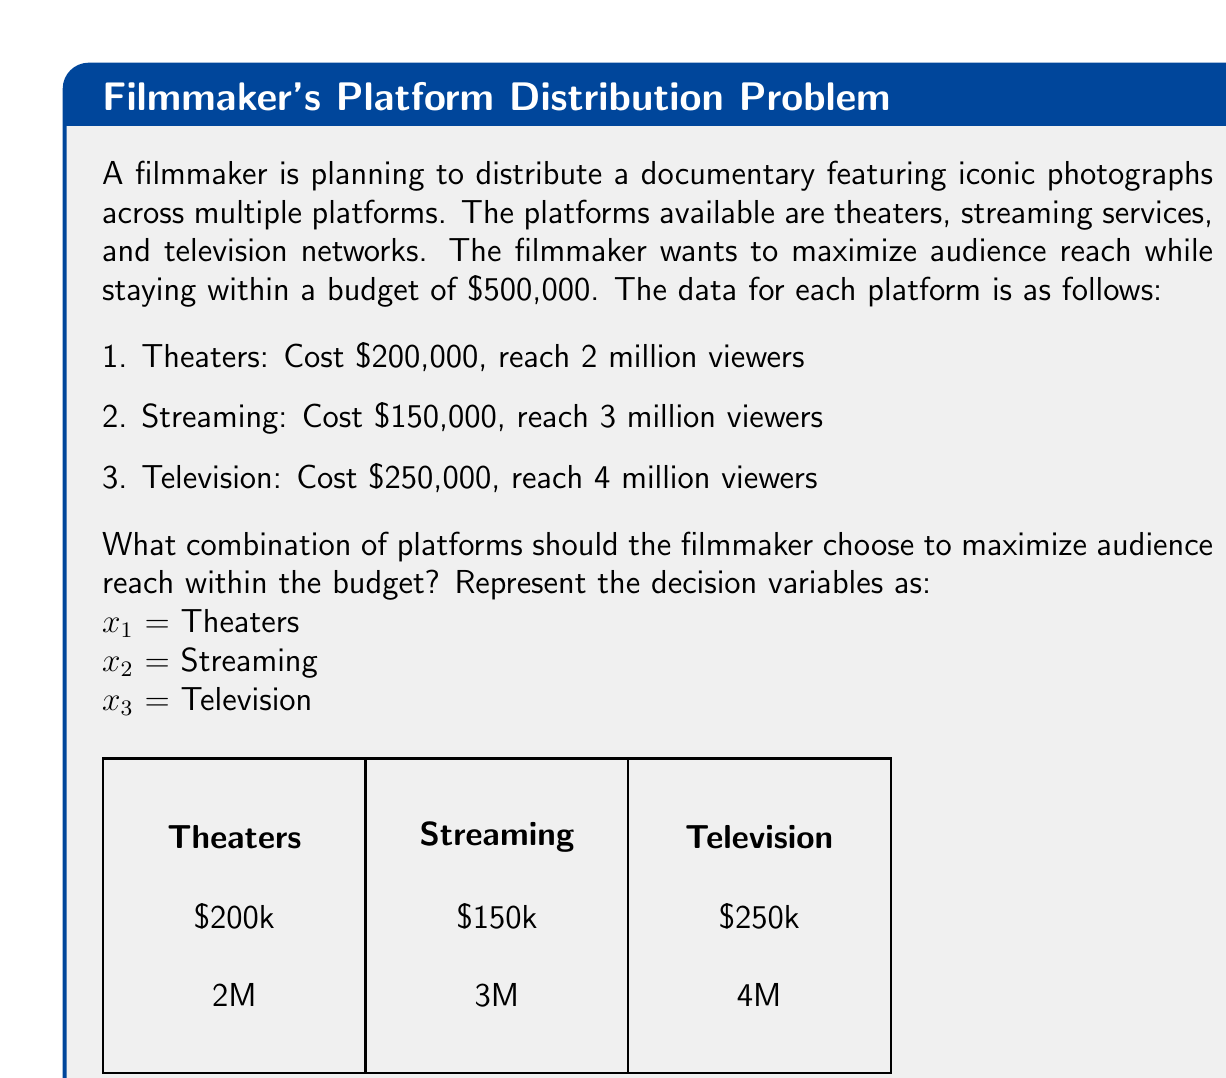Teach me how to tackle this problem. To solve this problem, we'll use integer programming:

1. Define the objective function:
   Maximize $Z = 2x_1 + 3x_2 + 4x_3$ (audience reach in millions)

2. Set up constraints:
   Budget constraint: $200x_1 + 150x_2 + 250x_3 \leq 500$ (in thousands)
   Binary constraints: $x_1, x_2, x_3 \in \{0,1\}$

3. Enumerate possible combinations:
   (0,0,0) = 0M viewers, $0
   (1,0,0) = 2M viewers, $200k
   (0,1,0) = 3M viewers, $150k
   (0,0,1) = 4M viewers, $250k
   (1,1,0) = 5M viewers, $350k
   (1,0,1) = 6M viewers, $450k
   (0,1,1) = 7M viewers, $400k
   (1,1,1) = 9M viewers, $600k (exceeds budget)

4. Identify the optimal solution:
   The combination (0,1,1) gives the maximum audience reach of 7 million viewers within the budget constraint.

Therefore, the filmmaker should choose streaming services and television networks for distribution.
Answer: $x_1 = 0, x_2 = 1, x_3 = 1$ (Streaming and Television) 